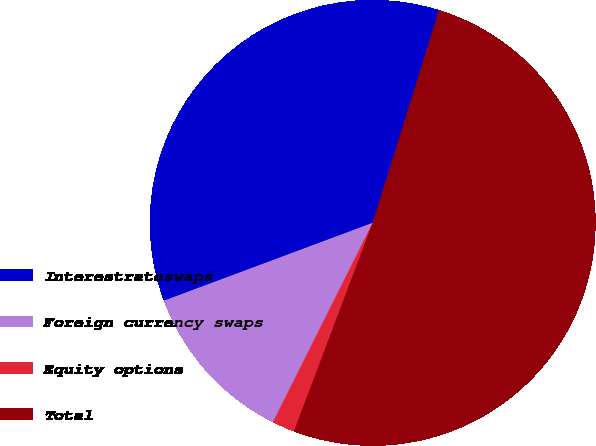Convert chart. <chart><loc_0><loc_0><loc_500><loc_500><pie_chart><fcel>Interestrateswaps<fcel>Foreign currency swaps<fcel>Equity options<fcel>Total<nl><fcel>35.5%<fcel>11.93%<fcel>1.64%<fcel>50.93%<nl></chart> 